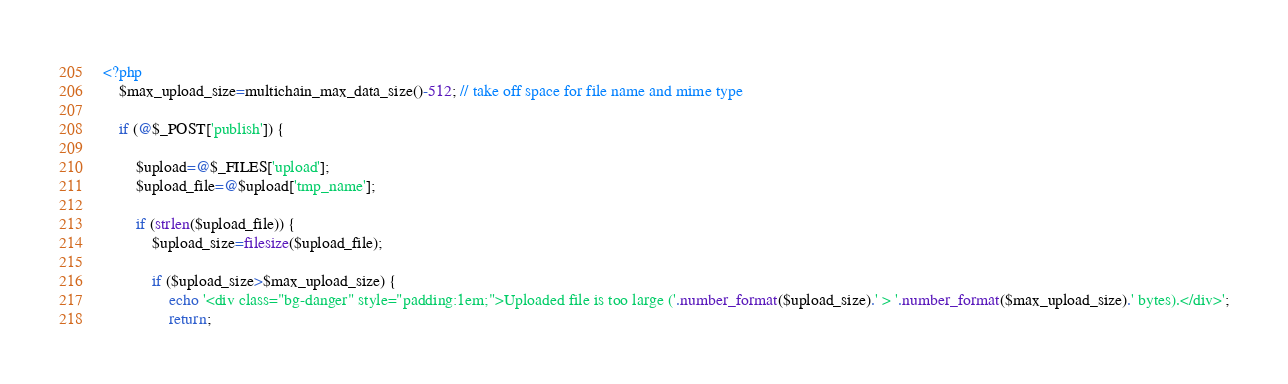<code> <loc_0><loc_0><loc_500><loc_500><_PHP_><?php
	$max_upload_size=multichain_max_data_size()-512; // take off space for file name and mime type

	if (@$_POST['publish']) {

		$upload=@$_FILES['upload'];
		$upload_file=@$upload['tmp_name'];

		if (strlen($upload_file)) {
			$upload_size=filesize($upload_file);

			if ($upload_size>$max_upload_size) {
				echo '<div class="bg-danger" style="padding:1em;">Uploaded file is too large ('.number_format($upload_size).' > '.number_format($max_upload_size).' bytes).</div>';
				return;
</code> 